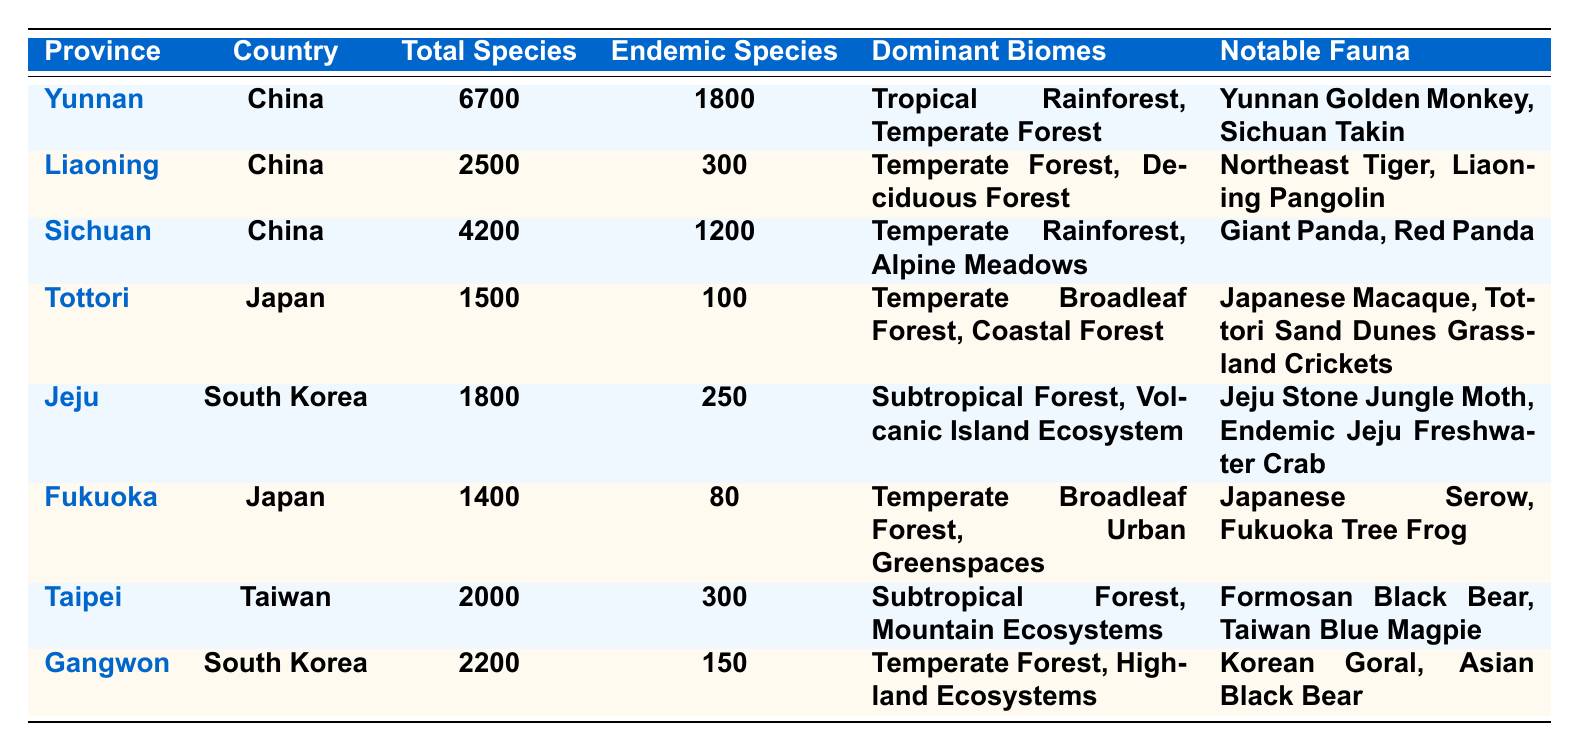What is the total number of species in Yunnan? The table lists Yunnan with a total species count of 6700.
Answer: 6700 How many endemic species are there in Sichuan? According to the table, Sichuan has 1200 endemic species listed.
Answer: 1200 Which province has the highest number of total species? By comparing the values in the Total Species column, Yunnan has the highest total with 6700 species.
Answer: Yunnan Which two provinces have the same number of endemic species? The table shows that Liaoning and Taipei both have 300 endemic species each.
Answer: Liaoning and Taipei Is the Giant Panda listed as notable fauna in the table? Yes, the Giant Panda is noted as notable fauna in Sichuan.
Answer: Yes How many total species are there across all provinces? The total species from all provinces can be calculated as follows: 6700 (Yunnan) + 2500 (Liaoning) + 4200 (Sichuan) + 1500 (Tottori) + 1800 (Jeju) + 1400 (Fukuoka) + 2000 (Taipei) + 2200 (Gangwon) = 19300.
Answer: 19300 Which province has the least number of total species and how many? By examining the Total Species column, Tottori has the least at 1500 total species.
Answer: Tottori, 1500 What are the dominant biomes in Jeju? Jeju's dominant biomes, as stated in the table, are Subtropical Forest and Volcanic Island Ecosystem.
Answer: Subtropical Forest, Volcanic Island Ecosystem How many provinces have more than 2000 total species? By checking the Total Species column, there are four provinces (Yunnan, Sichuan, Taipei, and Gangwon) that have more than 2000 total species.
Answer: 4 Which province has more endemic species, Jeju or Gangwon? Jeju has 250 endemic species while Gangwon has 150, so Jeju has more endemic species.
Answer: Jeju 